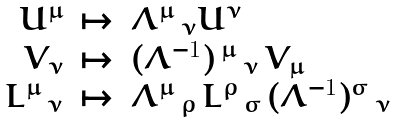<formula> <loc_0><loc_0><loc_500><loc_500>\begin{array} { r c l } U ^ { \mu } & \mapsto & \Lambda ^ { \mu } \, _ { \nu } U ^ { \nu } \\ V _ { \nu } & \mapsto & ( \Lambda ^ { - 1 } ) \, ^ { \mu } \, _ { \nu } \, V _ { \mu } \\ L ^ { \mu } \, _ { \nu } & \mapsto & \Lambda ^ { \mu } \, _ { \rho } \, L ^ { \rho } \, _ { \sigma } \, ( \Lambda ^ { - 1 } ) ^ { \sigma } \, _ { \nu } \end{array}</formula> 